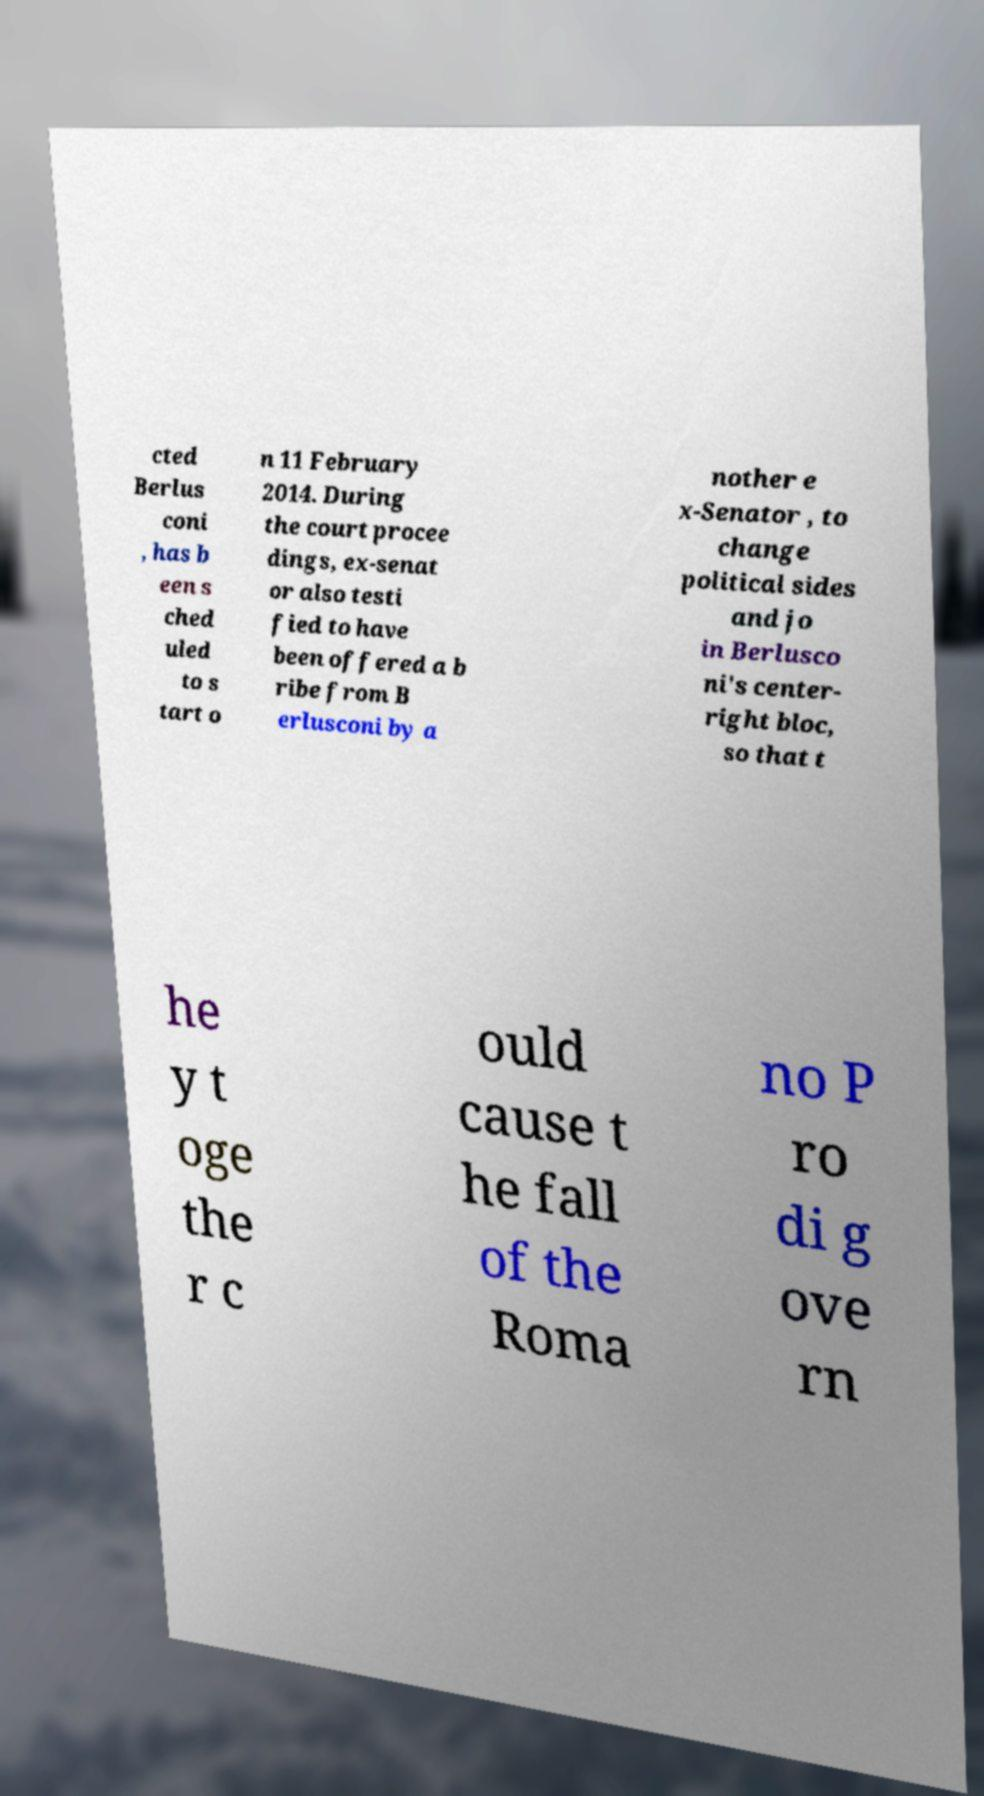Can you accurately transcribe the text from the provided image for me? cted Berlus coni , has b een s ched uled to s tart o n 11 February 2014. During the court procee dings, ex-senat or also testi fied to have been offered a b ribe from B erlusconi by a nother e x-Senator , to change political sides and jo in Berlusco ni's center- right bloc, so that t he y t oge the r c ould cause t he fall of the Roma no P ro di g ove rn 